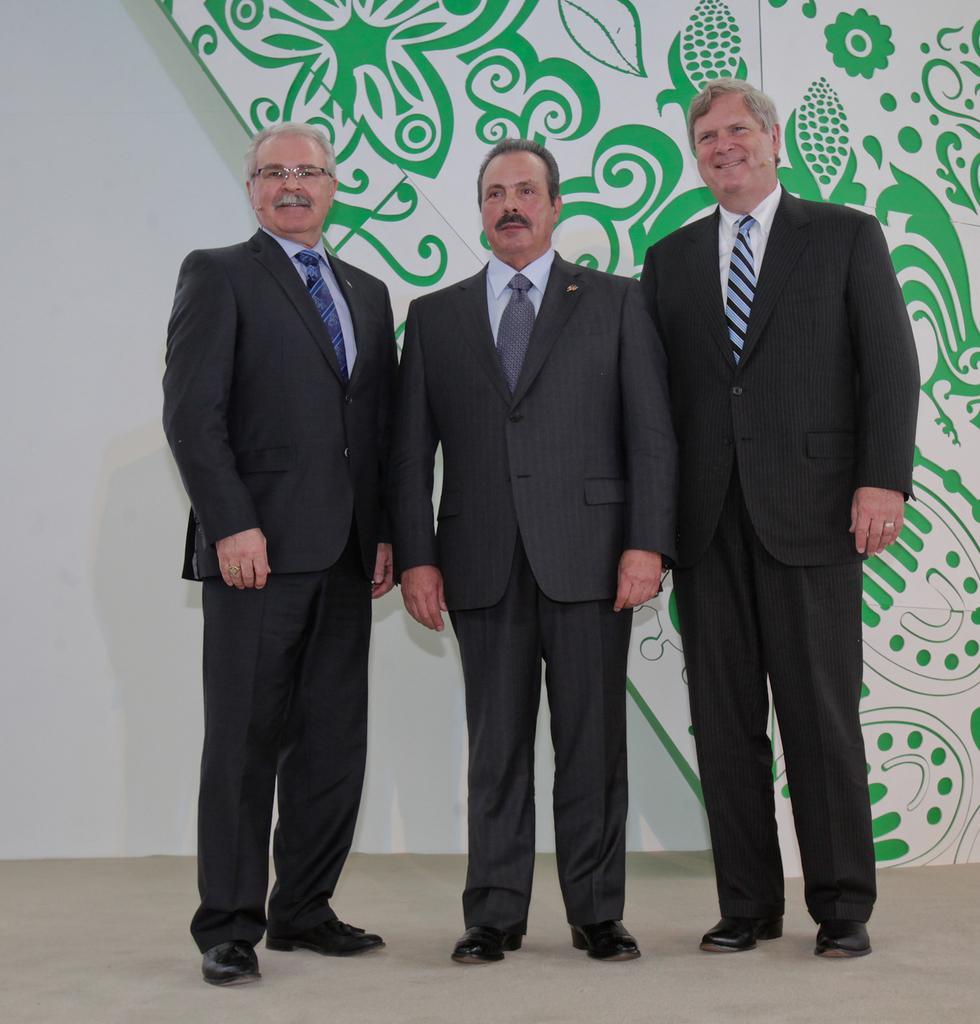In one or two sentences, can you explain what this image depicts? In this picture we can see there are three people standing on the floor and behind the people there is a wall and a design board. 